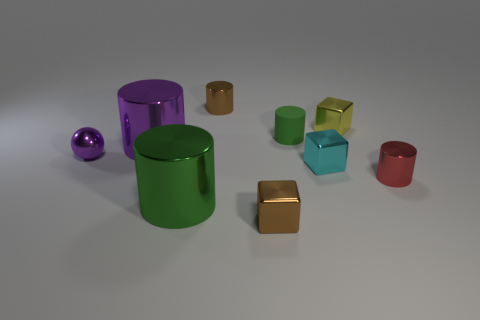Subtract 1 cubes. How many cubes are left? 2 Subtract all purple cylinders. How many cylinders are left? 4 Subtract all small brown cylinders. How many cylinders are left? 4 Subtract all yellow cylinders. Subtract all green blocks. How many cylinders are left? 5 Subtract all cylinders. How many objects are left? 4 Subtract 0 gray cubes. How many objects are left? 9 Subtract all green blocks. Subtract all red shiny cylinders. How many objects are left? 8 Add 5 yellow cubes. How many yellow cubes are left? 6 Add 6 small purple objects. How many small purple objects exist? 7 